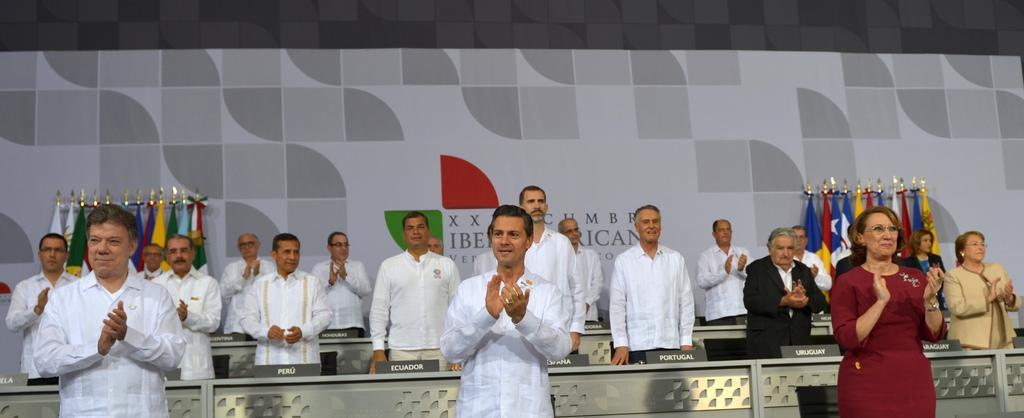Please provide a concise description of this image. Here in this picture we can see number of men and women standing on a stage, we can also see desks present with name cards on it over there and behind them we can see a banner, on which we can see different types of flag posts present on it over there. 